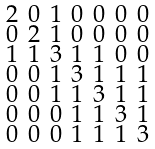Convert formula to latex. <formula><loc_0><loc_0><loc_500><loc_500>\begin{smallmatrix} 2 & 0 & 1 & 0 & 0 & 0 & 0 \\ 0 & 2 & 1 & 0 & 0 & 0 & 0 \\ 1 & 1 & 3 & 1 & 1 & 0 & 0 \\ 0 & 0 & 1 & 3 & 1 & 1 & 1 \\ 0 & 0 & 1 & 1 & 3 & 1 & 1 \\ 0 & 0 & 0 & 1 & 1 & 3 & 1 \\ 0 & 0 & 0 & 1 & 1 & 1 & 3 \end{smallmatrix}</formula> 